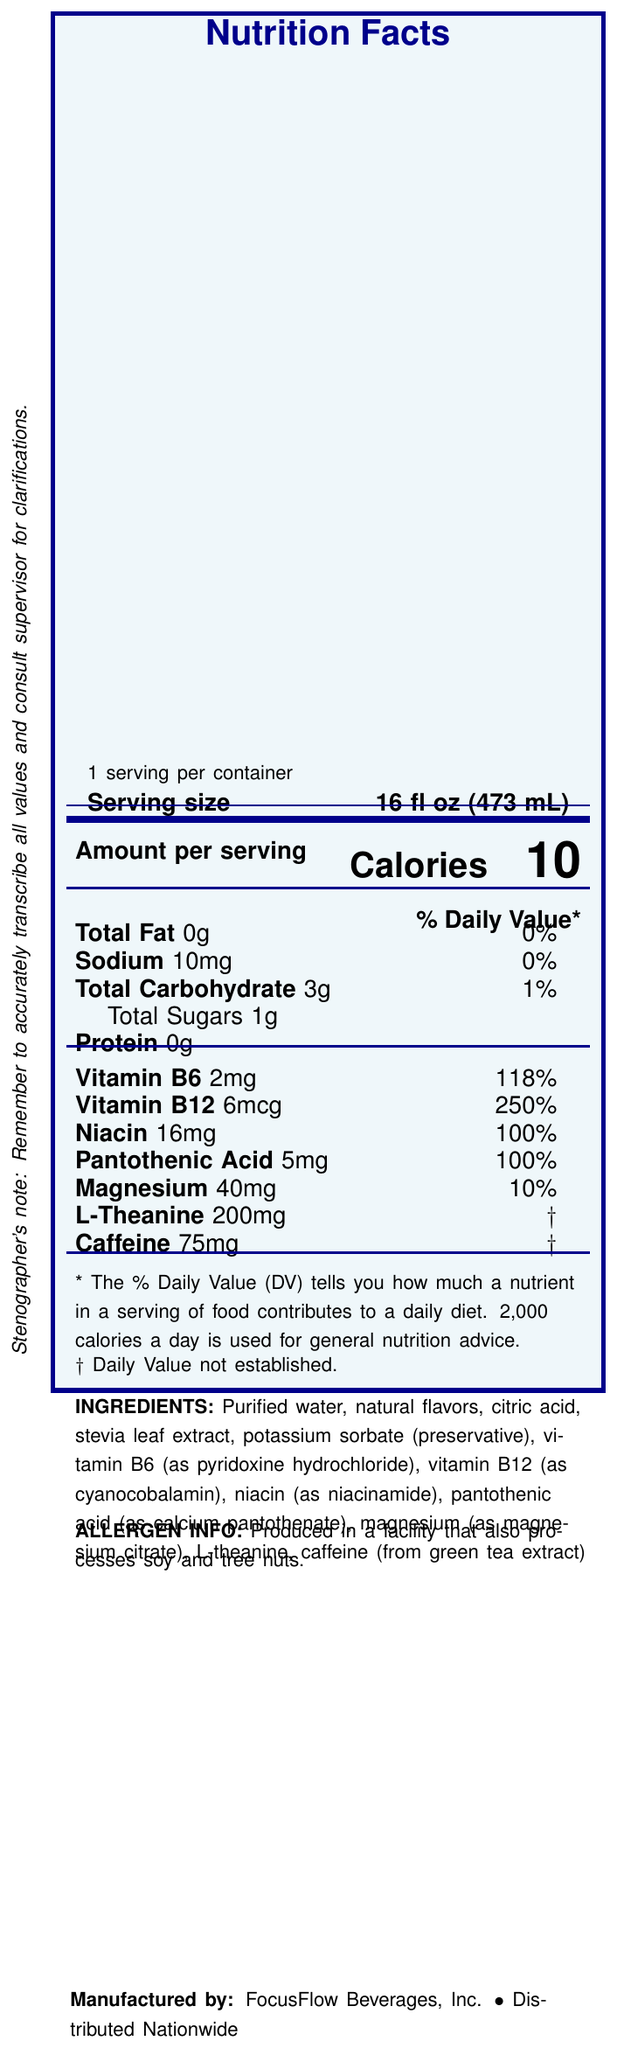What is the serving size of ClearMind Focus Water? The serving size is listed at the top of the nutrition facts as "Serving size, 16 fl oz (473 mL)".
Answer: 16 fl oz (473 mL) How many calories are in one serving of ClearMind Focus Water? The calories are listed as "Calories 10" in bold within the "Amount per serving" section of the document.
Answer: 10 What percentage of the daily value of Vitamin B12 does one serving of ClearMind Focus Water provide? The percentage is listed next to Vitamin B12 in the vitamins section: "Vitamin B12 6mcg 250%".
Answer: 250% How much caffeine is in a serving of ClearMind Focus Water? The amount of caffeine is detailed as "Caffeine 75mg" in the vitamins and minerals section.
Answer: 75mg List two ingredients in ClearMind Focus Water. The ingredients are listed at the bottom and include "Purified water" and "natural flavors".
Answer: Purified water, natural flavors How much total fat does ClearMind Focus Water contain? The total fat content is listed as "Total Fat 0g".
Answer: 0g Which manufacturer produces ClearMind Focus Water? A. Clear Beverage Co. B. HealthFlow Inc. C. FocusFlow Beverages, Inc. The document states at the bottom that ClearMind Focus Water is manufactured by "FocusFlow Beverages, Inc.".
Answer: C What is the percentage of daily value for Magnesium in ClearMind Focus Water? A. 5% B. 10% C. 15% The percentage is listed next to Magnesium as "Magnesium 40mg 10%".
Answer: B Is L-Theanine content in ClearMind Focus Water associated with a specific daily value percentage? The document uses a dagger (†) symbol to indicate that the daily value for L-Theanine is not established.
Answer: No What allergens might be found in ClearMind Focus Water due to processing? The allergen information states that the product is "Produced in a facility that also processes soy and tree nuts."
Answer: Soy and tree nuts Summarize the purpose and key nutritional information of the document This summary encapsulates all the major points of the nutrition facts label, from the product's name and purpose to detailed nutritional contents and additional notes.
Answer: The document provides the nutrition facts for ClearMind Focus Water, a vitamin-fortified beverage aimed at improving focus and mental clarity. It lists serving size, calorie content, and detailed nutritional information including vitamins, minerals, and ingredients. It highlights that the beverage contains 10 calories, 0g of fat, vitamins such as B6, B12, niacin, and pantothenic acid, and has 75mg of caffeine and 200mg of L-Theanine. It also includes information on allergens and manufacturing details. What specific health benefit does ClearMind Focus Water claim to provide? While the document implies benefits related to focus and mental clarity through its name "ClearMind Focus Water," it does not explicitly provide detailed health claims within the visual information provided.
Answer: Not enough information 